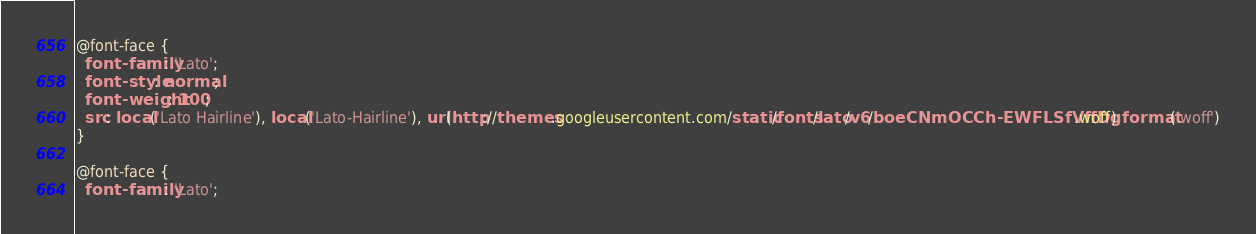<code> <loc_0><loc_0><loc_500><loc_500><_CSS_>@font-face {
  font-family: 'Lato';
  font-style: normal;
  font-weight: 100;
  src: local('Lato Hairline'), local('Lato-Hairline'), url(http://themes.googleusercontent.com/static/fonts/lato/v6/boeCNmOCCh-EWFLSfVffDg.woff) format('woff')
}

@font-face {
  font-family: 'Lato';</code> 